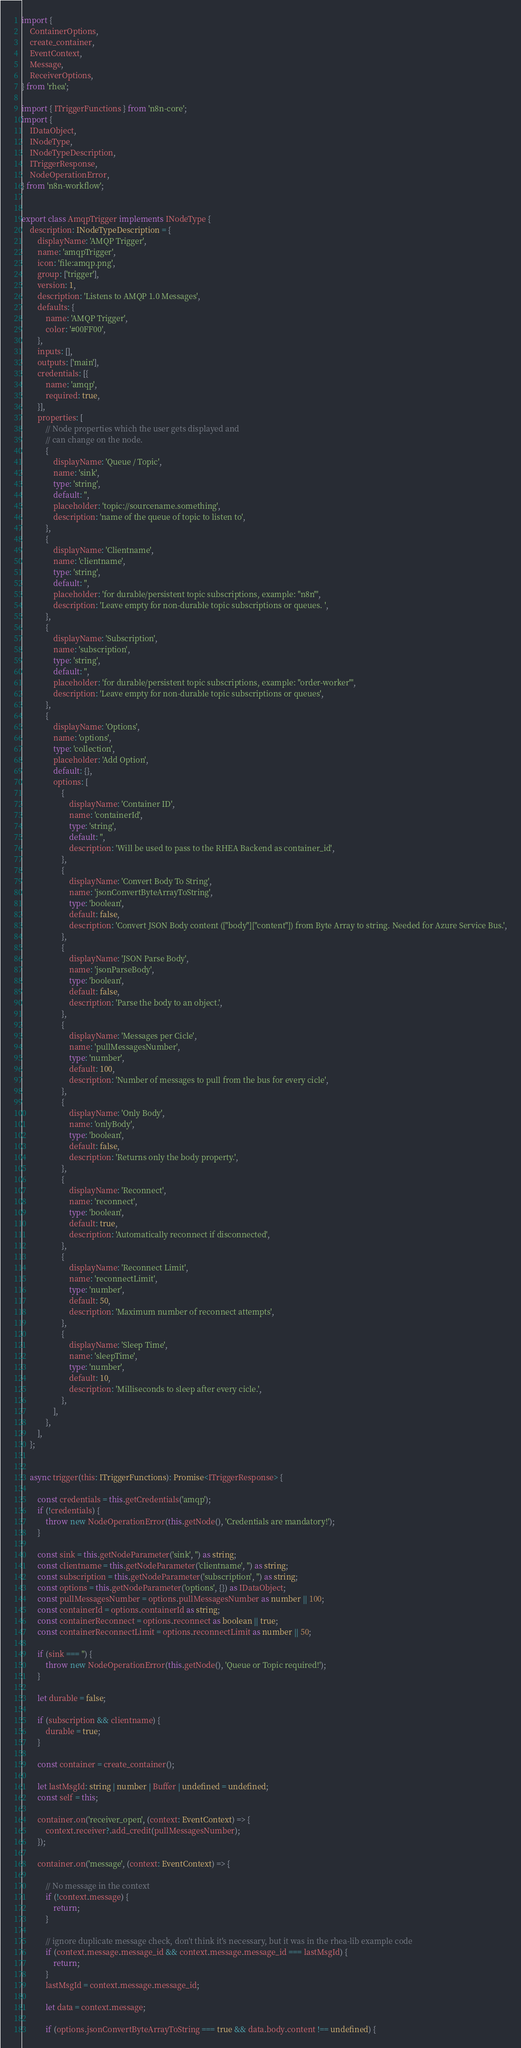<code> <loc_0><loc_0><loc_500><loc_500><_TypeScript_>import {
	ContainerOptions,
	create_container,
	EventContext,
	Message,
	ReceiverOptions,
} from 'rhea';

import { ITriggerFunctions } from 'n8n-core';
import {
	IDataObject,
	INodeType,
	INodeTypeDescription,
	ITriggerResponse,
	NodeOperationError,
} from 'n8n-workflow';


export class AmqpTrigger implements INodeType {
	description: INodeTypeDescription = {
		displayName: 'AMQP Trigger',
		name: 'amqpTrigger',
		icon: 'file:amqp.png',
		group: ['trigger'],
		version: 1,
		description: 'Listens to AMQP 1.0 Messages',
		defaults: {
			name: 'AMQP Trigger',
			color: '#00FF00',
		},
		inputs: [],
		outputs: ['main'],
		credentials: [{
			name: 'amqp',
			required: true,
		}],
		properties: [
			// Node properties which the user gets displayed and
			// can change on the node.
			{
				displayName: 'Queue / Topic',
				name: 'sink',
				type: 'string',
				default: '',
				placeholder: 'topic://sourcename.something',
				description: 'name of the queue of topic to listen to',
			},
			{
				displayName: 'Clientname',
				name: 'clientname',
				type: 'string',
				default: '',
				placeholder: 'for durable/persistent topic subscriptions, example: "n8n"',
				description: 'Leave empty for non-durable topic subscriptions or queues. ',
			},
			{
				displayName: 'Subscription',
				name: 'subscription',
				type: 'string',
				default: '',
				placeholder: 'for durable/persistent topic subscriptions, example: "order-worker"',
				description: 'Leave empty for non-durable topic subscriptions or queues',
			},
			{
				displayName: 'Options',
				name: 'options',
				type: 'collection',
				placeholder: 'Add Option',
				default: {},
				options: [
					{
						displayName: 'Container ID',
						name: 'containerId',
						type: 'string',
						default: '',
						description: 'Will be used to pass to the RHEA Backend as container_id',
					},
					{
						displayName: 'Convert Body To String',
						name: 'jsonConvertByteArrayToString',
						type: 'boolean',
						default: false,
						description: 'Convert JSON Body content (["body"]["content"]) from Byte Array to string. Needed for Azure Service Bus.',
					},
					{
						displayName: 'JSON Parse Body',
						name: 'jsonParseBody',
						type: 'boolean',
						default: false,
						description: 'Parse the body to an object.',
					},
					{
						displayName: 'Messages per Cicle',
						name: 'pullMessagesNumber',
						type: 'number',
						default: 100,
						description: 'Number of messages to pull from the bus for every cicle',
					},
					{
						displayName: 'Only Body',
						name: 'onlyBody',
						type: 'boolean',
						default: false,
						description: 'Returns only the body property.',
					},
					{
						displayName: 'Reconnect',
						name: 'reconnect',
						type: 'boolean',
						default: true,
						description: 'Automatically reconnect if disconnected',
					},
					{
						displayName: 'Reconnect Limit',
						name: 'reconnectLimit',
						type: 'number',
						default: 50,
						description: 'Maximum number of reconnect attempts',
					},
					{
						displayName: 'Sleep Time',
						name: 'sleepTime',
						type: 'number',
						default: 10,
						description: 'Milliseconds to sleep after every cicle.',
					},
				],
			},
		],
	};


	async trigger(this: ITriggerFunctions): Promise<ITriggerResponse> {

		const credentials = this.getCredentials('amqp');
		if (!credentials) {
			throw new NodeOperationError(this.getNode(), 'Credentials are mandatory!');
		}

		const sink = this.getNodeParameter('sink', '') as string;
		const clientname = this.getNodeParameter('clientname', '') as string;
		const subscription = this.getNodeParameter('subscription', '') as string;
		const options = this.getNodeParameter('options', {}) as IDataObject;
		const pullMessagesNumber = options.pullMessagesNumber as number || 100;
		const containerId = options.containerId as string;
		const containerReconnect = options.reconnect as boolean || true;
		const containerReconnectLimit = options.reconnectLimit as number || 50;

		if (sink === '') {
			throw new NodeOperationError(this.getNode(), 'Queue or Topic required!');
		}

		let durable = false;

		if (subscription && clientname) {
			durable = true;
		}

		const container = create_container();

		let lastMsgId: string | number | Buffer | undefined = undefined;
		const self = this;

		container.on('receiver_open', (context: EventContext) => {
			context.receiver?.add_credit(pullMessagesNumber);
		});

		container.on('message', (context: EventContext) => {

			// No message in the context
			if (!context.message) {
				return;
			}

			// ignore duplicate message check, don't think it's necessary, but it was in the rhea-lib example code
			if (context.message.message_id && context.message.message_id === lastMsgId) {
				return;
			}
			lastMsgId = context.message.message_id;

			let data = context.message;

			if (options.jsonConvertByteArrayToString === true && data.body.content !== undefined) {</code> 